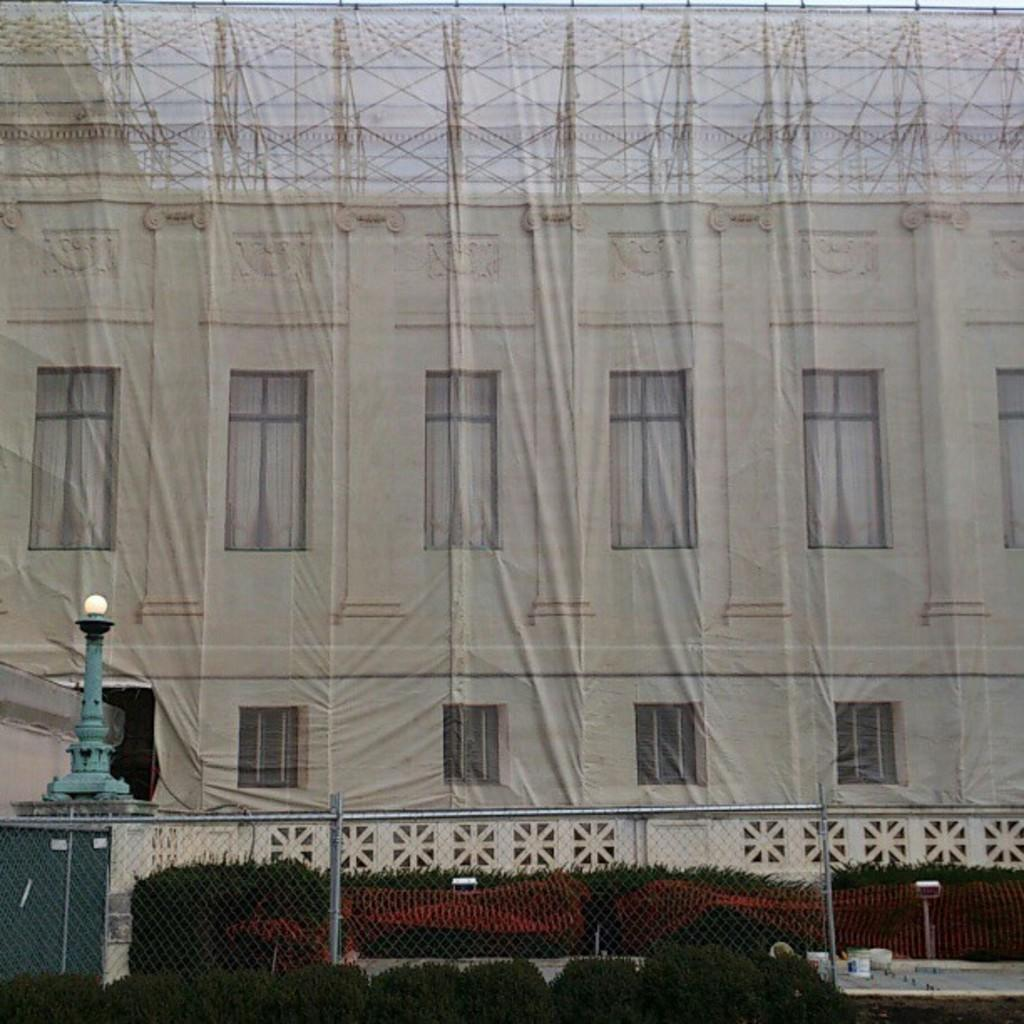What type of structure is visible in the image? There is a building in the image. What is located in front of the building? There is fencing in front of the building. Are there any plants visible in the image? Yes, there are plants in front of the building. Can you describe the blue object on the left side of the image? There is a blue color pole on the left side of the image. What type of vegetable is being used to clean the sidewalk in the image? There is no vegetable or sidewalk present in the image. 